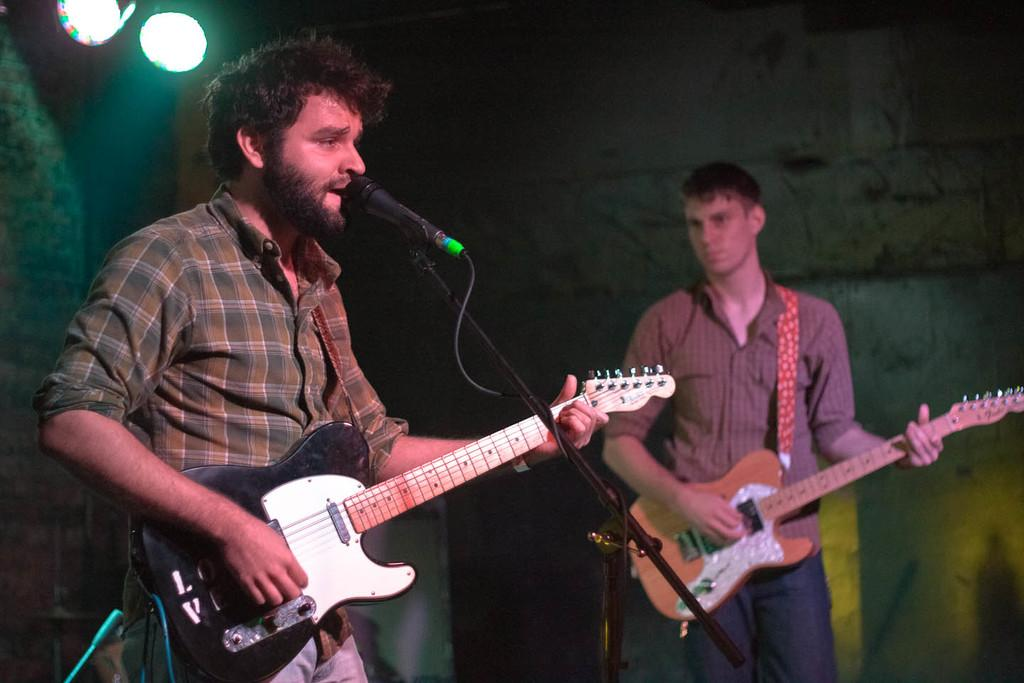How many people are in the image? There are two people in the image. What is one person doing in the image? One person is holding a guitar. What is the person with the guitar doing? The person with the guitar is singing with the help of a microphone. What is the other person doing in the image? The other person is looking at the person with the guitar. What type of arch can be seen in the image? There is no arch present in the image. What decision is the person with the guitar making in the image? The image does not show the person with the guitar making any decisions. 